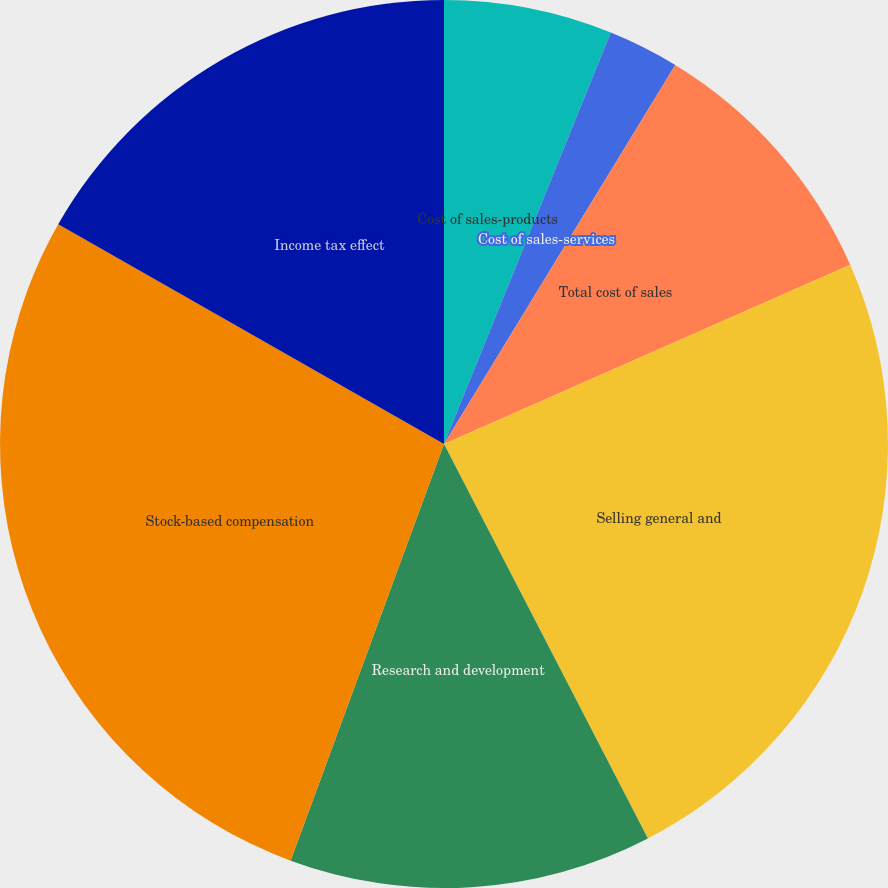Convert chart to OTSL. <chart><loc_0><loc_0><loc_500><loc_500><pie_chart><fcel>Cost of sales-products<fcel>Cost of sales-services<fcel>Total cost of sales<fcel>Selling general and<fcel>Research and development<fcel>Stock-based compensation<fcel>Income tax effect<nl><fcel>6.13%<fcel>2.59%<fcel>9.67%<fcel>24.02%<fcel>13.21%<fcel>27.63%<fcel>16.76%<nl></chart> 